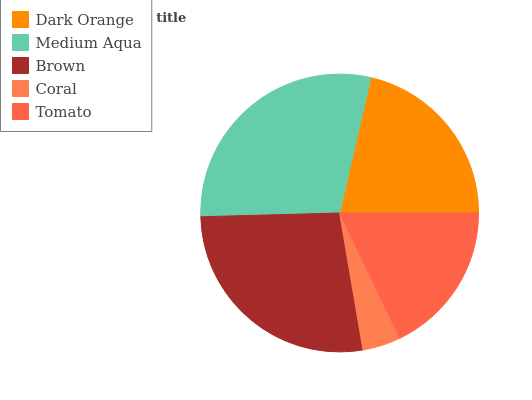Is Coral the minimum?
Answer yes or no. Yes. Is Medium Aqua the maximum?
Answer yes or no. Yes. Is Brown the minimum?
Answer yes or no. No. Is Brown the maximum?
Answer yes or no. No. Is Medium Aqua greater than Brown?
Answer yes or no. Yes. Is Brown less than Medium Aqua?
Answer yes or no. Yes. Is Brown greater than Medium Aqua?
Answer yes or no. No. Is Medium Aqua less than Brown?
Answer yes or no. No. Is Dark Orange the high median?
Answer yes or no. Yes. Is Dark Orange the low median?
Answer yes or no. Yes. Is Medium Aqua the high median?
Answer yes or no. No. Is Medium Aqua the low median?
Answer yes or no. No. 